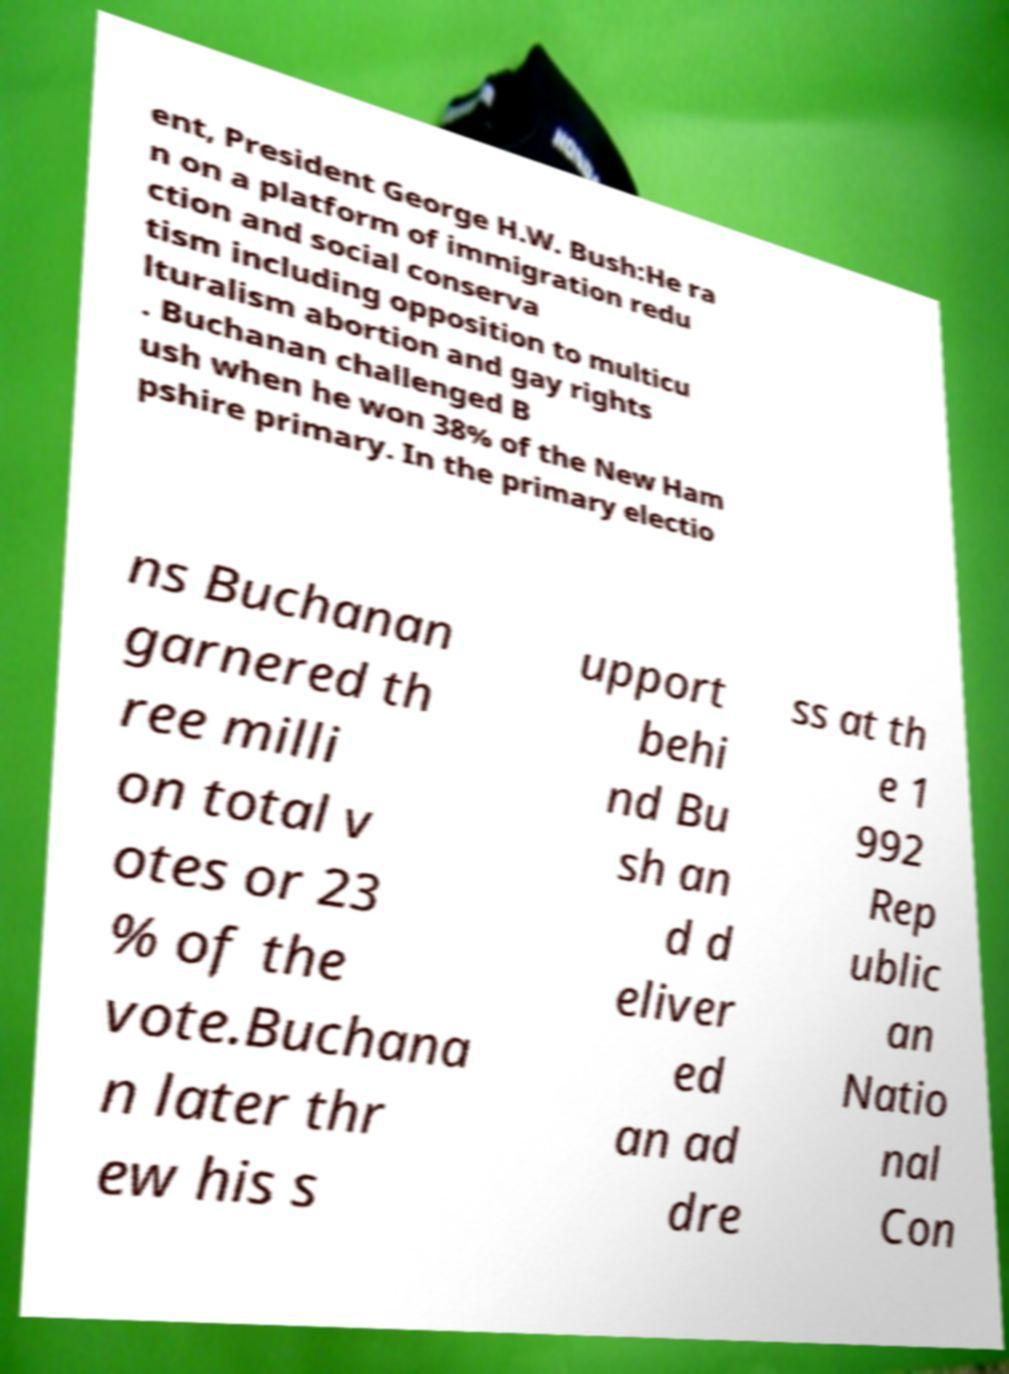Could you assist in decoding the text presented in this image and type it out clearly? ent, President George H.W. Bush:He ra n on a platform of immigration redu ction and social conserva tism including opposition to multicu lturalism abortion and gay rights . Buchanan challenged B ush when he won 38% of the New Ham pshire primary. In the primary electio ns Buchanan garnered th ree milli on total v otes or 23 % of the vote.Buchana n later thr ew his s upport behi nd Bu sh an d d eliver ed an ad dre ss at th e 1 992 Rep ublic an Natio nal Con 